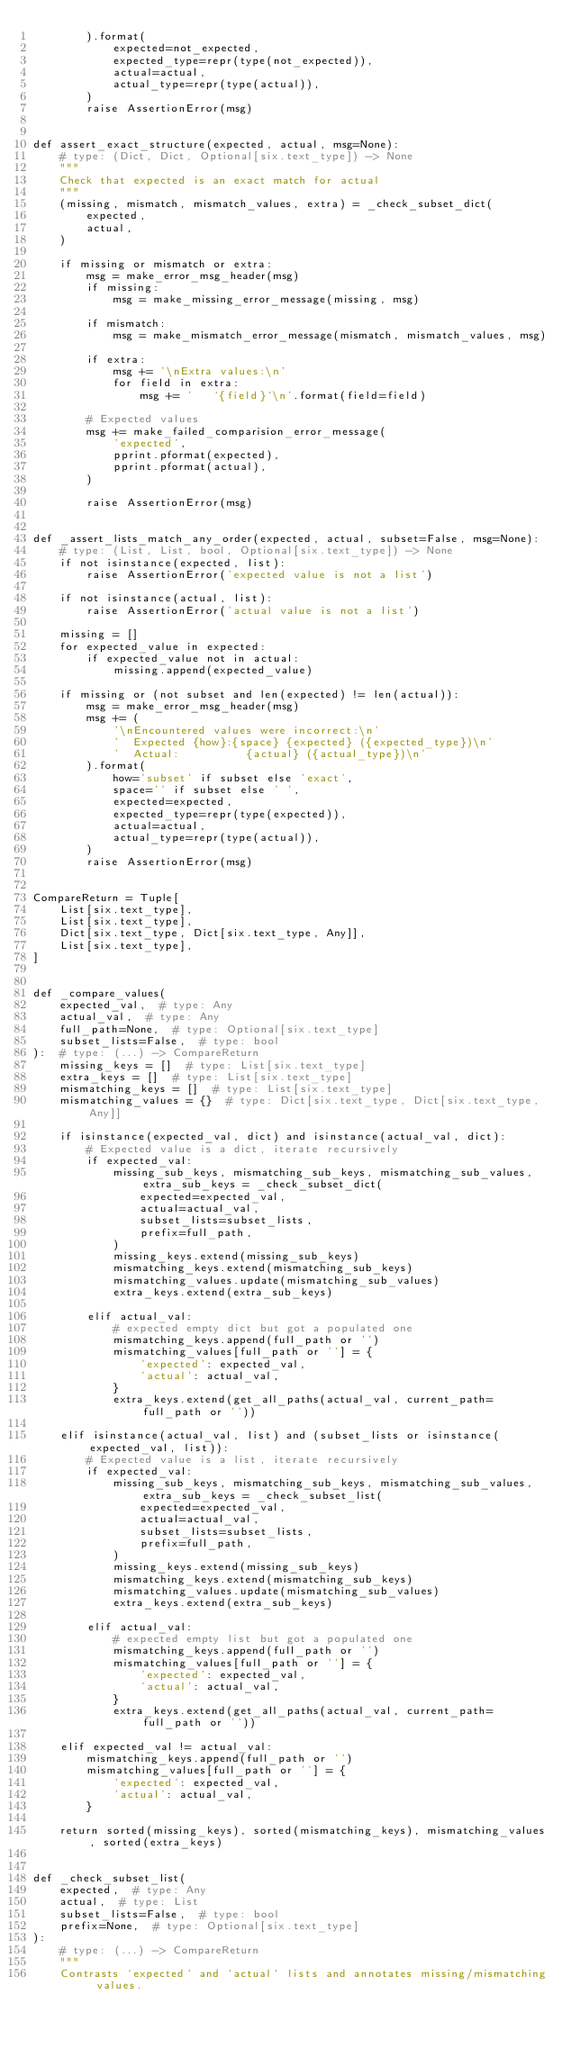Convert code to text. <code><loc_0><loc_0><loc_500><loc_500><_Python_>        ).format(
            expected=not_expected,
            expected_type=repr(type(not_expected)),
            actual=actual,
            actual_type=repr(type(actual)),
        )
        raise AssertionError(msg)


def assert_exact_structure(expected, actual, msg=None):
    # type: (Dict, Dict, Optional[six.text_type]) -> None
    """
    Check that expected is an exact match for actual
    """
    (missing, mismatch, mismatch_values, extra) = _check_subset_dict(
        expected,
        actual,
    )

    if missing or mismatch or extra:
        msg = make_error_msg_header(msg)
        if missing:
            msg = make_missing_error_message(missing, msg)

        if mismatch:
            msg = make_mismatch_error_message(mismatch, mismatch_values, msg)

        if extra:
            msg += '\nExtra values:\n'
            for field in extra:
                msg += '   `{field}`\n'.format(field=field)

        # Expected values
        msg += make_failed_comparision_error_message(
            'expected',
            pprint.pformat(expected),
            pprint.pformat(actual),
        )

        raise AssertionError(msg)


def _assert_lists_match_any_order(expected, actual, subset=False, msg=None):
    # type: (List, List, bool, Optional[six.text_type]) -> None
    if not isinstance(expected, list):
        raise AssertionError('expected value is not a list')

    if not isinstance(actual, list):
        raise AssertionError('actual value is not a list')

    missing = []
    for expected_value in expected:
        if expected_value not in actual:
            missing.append(expected_value)

    if missing or (not subset and len(expected) != len(actual)):
        msg = make_error_msg_header(msg)
        msg += (
            '\nEncountered values were incorrect:\n'
            '  Expected {how}:{space} {expected} ({expected_type})\n'
            '  Actual:          {actual} ({actual_type})\n'
        ).format(
            how='subset' if subset else 'exact',
            space='' if subset else ' ',
            expected=expected,
            expected_type=repr(type(expected)),
            actual=actual,
            actual_type=repr(type(actual)),
        )
        raise AssertionError(msg)


CompareReturn = Tuple[
    List[six.text_type],
    List[six.text_type],
    Dict[six.text_type, Dict[six.text_type, Any]],
    List[six.text_type],
]


def _compare_values(
    expected_val,  # type: Any
    actual_val,  # type: Any
    full_path=None,  # type: Optional[six.text_type]
    subset_lists=False,  # type: bool
):  # type: (...) -> CompareReturn
    missing_keys = []  # type: List[six.text_type]
    extra_keys = []  # type: List[six.text_type]
    mismatching_keys = []  # type: List[six.text_type]
    mismatching_values = {}  # type: Dict[six.text_type, Dict[six.text_type, Any]]

    if isinstance(expected_val, dict) and isinstance(actual_val, dict):
        # Expected value is a dict, iterate recursively
        if expected_val:
            missing_sub_keys, mismatching_sub_keys, mismatching_sub_values, extra_sub_keys = _check_subset_dict(
                expected=expected_val,
                actual=actual_val,
                subset_lists=subset_lists,
                prefix=full_path,
            )
            missing_keys.extend(missing_sub_keys)
            mismatching_keys.extend(mismatching_sub_keys)
            mismatching_values.update(mismatching_sub_values)
            extra_keys.extend(extra_sub_keys)

        elif actual_val:
            # expected empty dict but got a populated one
            mismatching_keys.append(full_path or '')
            mismatching_values[full_path or ''] = {
                'expected': expected_val,
                'actual': actual_val,
            }
            extra_keys.extend(get_all_paths(actual_val, current_path=full_path or ''))

    elif isinstance(actual_val, list) and (subset_lists or isinstance(expected_val, list)):
        # Expected value is a list, iterate recursively
        if expected_val:
            missing_sub_keys, mismatching_sub_keys, mismatching_sub_values, extra_sub_keys = _check_subset_list(
                expected=expected_val,
                actual=actual_val,
                subset_lists=subset_lists,
                prefix=full_path,
            )
            missing_keys.extend(missing_sub_keys)
            mismatching_keys.extend(mismatching_sub_keys)
            mismatching_values.update(mismatching_sub_values)
            extra_keys.extend(extra_sub_keys)

        elif actual_val:
            # expected empty list but got a populated one
            mismatching_keys.append(full_path or '')
            mismatching_values[full_path or ''] = {
                'expected': expected_val,
                'actual': actual_val,
            }
            extra_keys.extend(get_all_paths(actual_val, current_path=full_path or ''))

    elif expected_val != actual_val:
        mismatching_keys.append(full_path or '')
        mismatching_values[full_path or ''] = {
            'expected': expected_val,
            'actual': actual_val,
        }

    return sorted(missing_keys), sorted(mismatching_keys), mismatching_values, sorted(extra_keys)


def _check_subset_list(
    expected,  # type: Any
    actual,  # type: List
    subset_lists=False,  # type: bool
    prefix=None,  # type: Optional[six.text_type]
):
    # type: (...) -> CompareReturn
    """
    Contrasts `expected` and `actual` lists and annotates missing/mismatching values.
</code> 